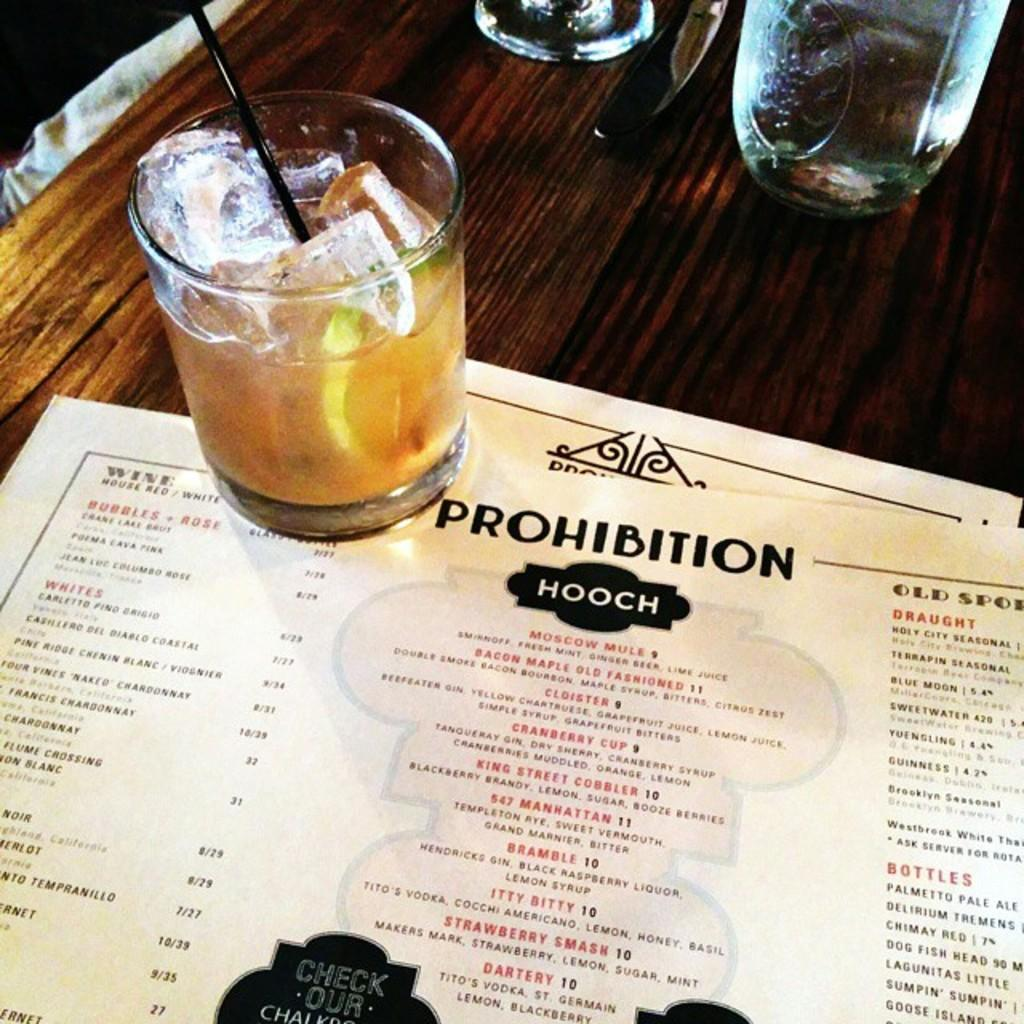What piece of furniture is present in the image? There is a table in the image. What items can be seen on the table? There are glasses, a knife, menu cards, and a drink on the table. What might be used to cut something in the image? There is a knife on the table that could be used for cutting. What might be used to make a selection from available options in the image? The menu cards on the table could be used to make a selection from available options. What type of music can be heard playing in the background of the image? There is no music present in the image, as it only shows a table with various items on it. 